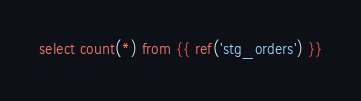Convert code to text. <code><loc_0><loc_0><loc_500><loc_500><_SQL_>

select count(*) from {{ ref('stg_orders') }}
</code> 